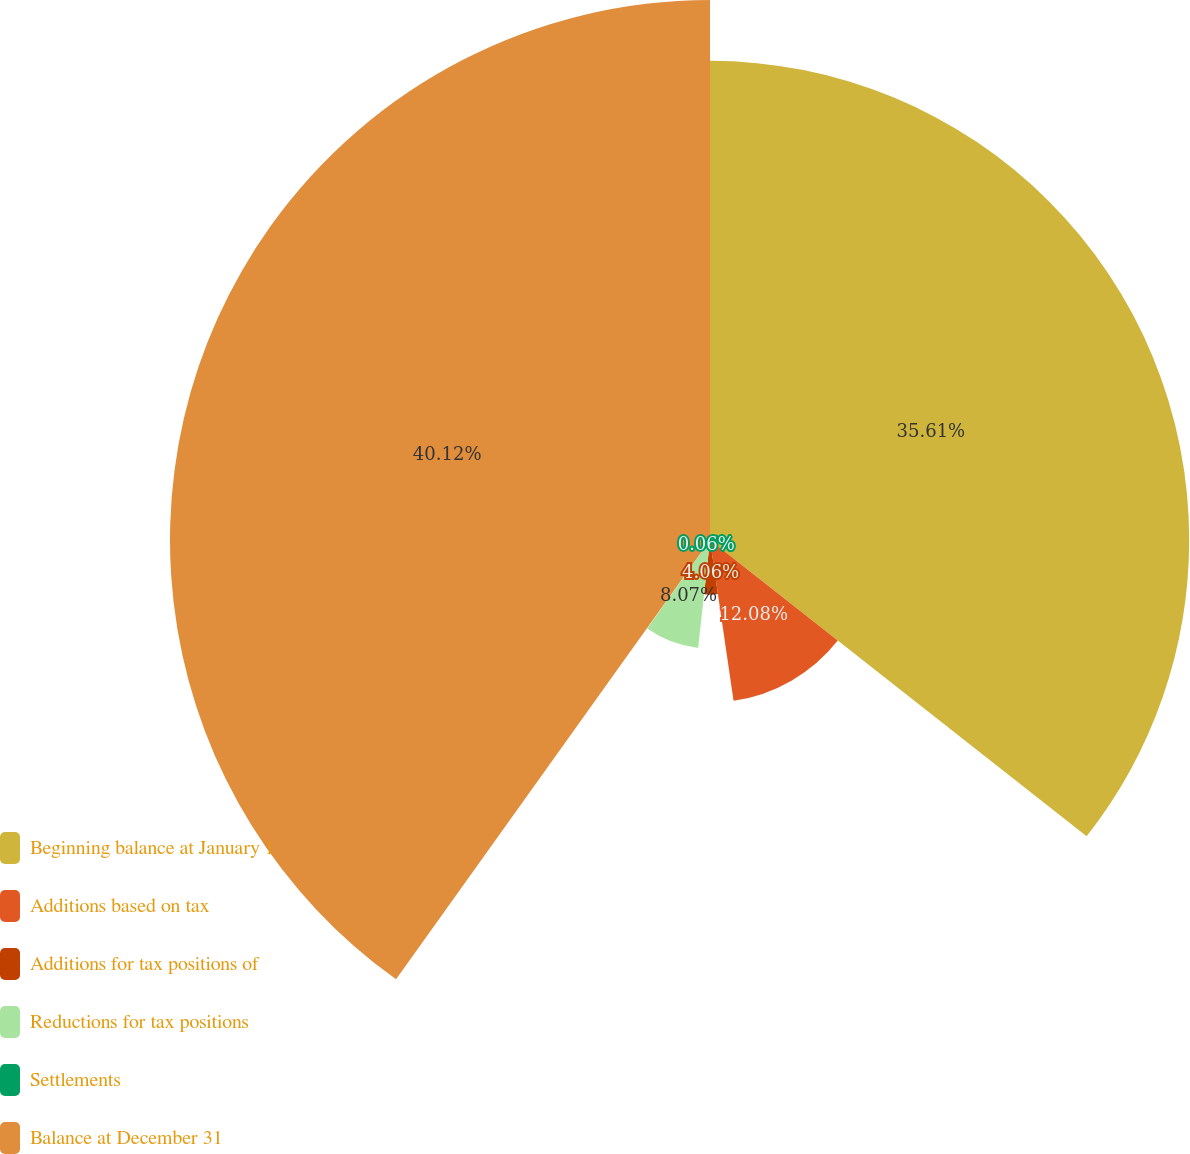<chart> <loc_0><loc_0><loc_500><loc_500><pie_chart><fcel>Beginning balance at January 1<fcel>Additions based on tax<fcel>Additions for tax positions of<fcel>Reductions for tax positions<fcel>Settlements<fcel>Balance at December 31<nl><fcel>35.61%<fcel>12.08%<fcel>4.06%<fcel>8.07%<fcel>0.06%<fcel>40.13%<nl></chart> 